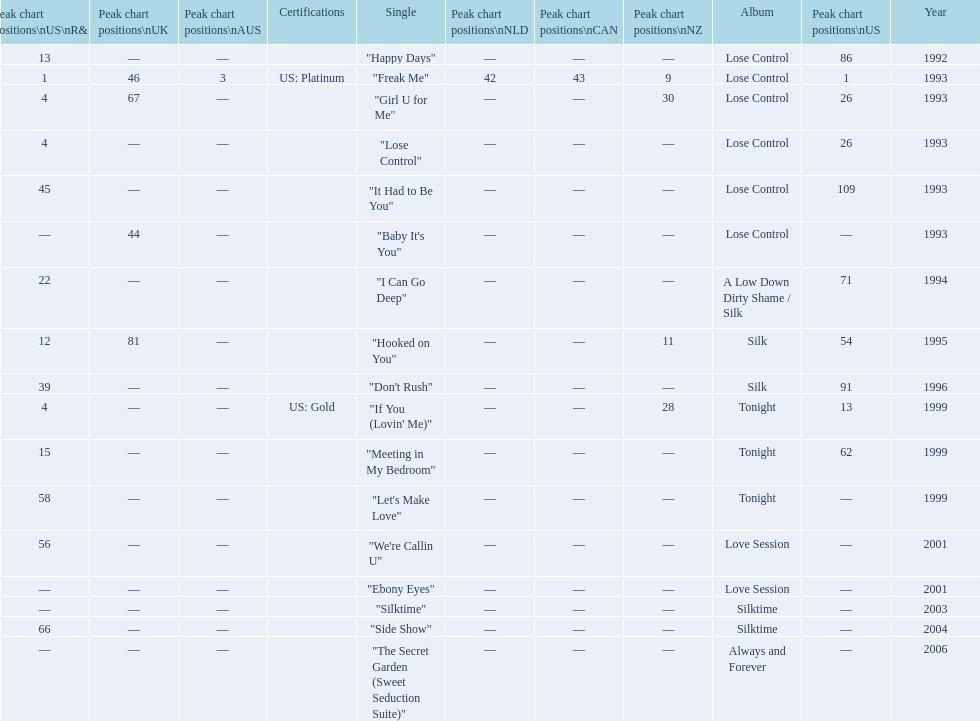Which single is the most in terms of how many times it charted? "Freak Me". 